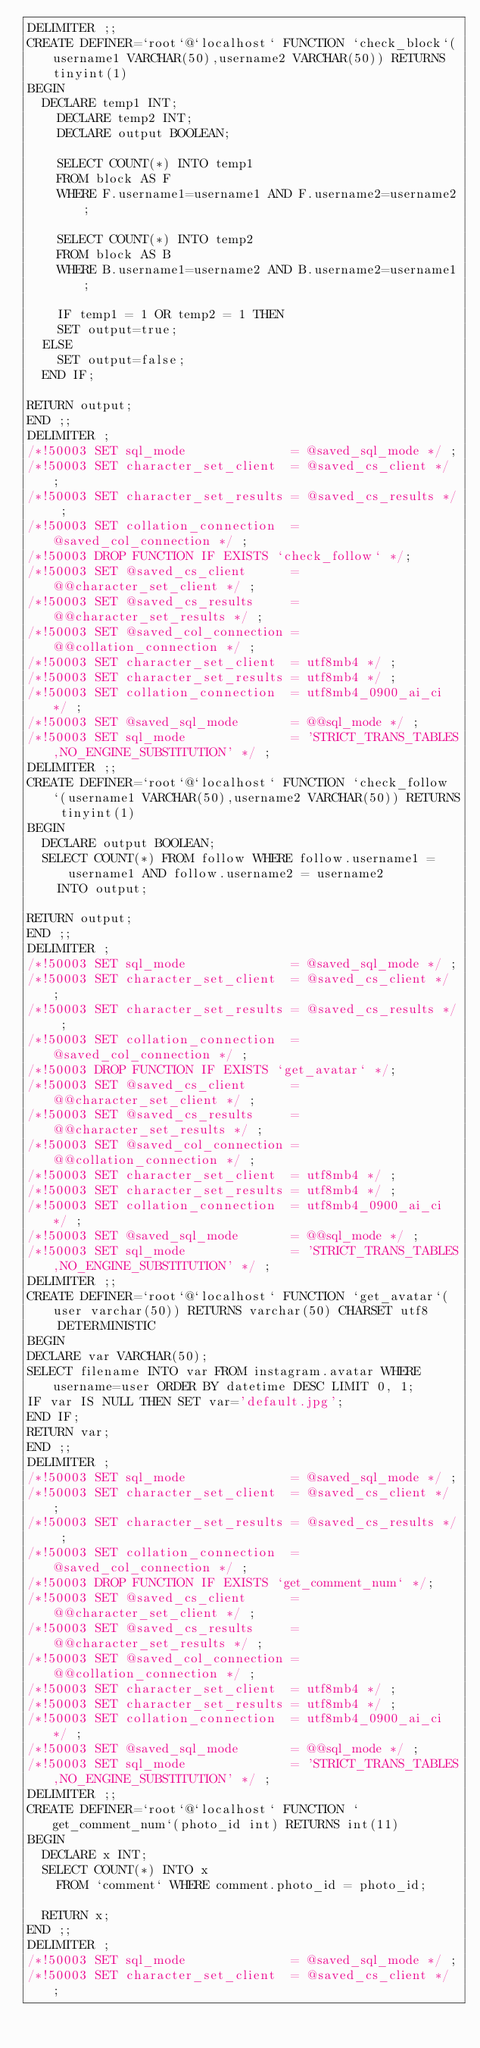Convert code to text. <code><loc_0><loc_0><loc_500><loc_500><_SQL_>DELIMITER ;;
CREATE DEFINER=`root`@`localhost` FUNCTION `check_block`(username1 VARCHAR(50),username2 VARCHAR(50)) RETURNS tinyint(1)
BEGIN
	DECLARE temp1 INT;
    DECLARE temp2 INT;
    DECLARE output BOOLEAN;
    
    SELECT COUNT(*) INTO temp1
    FROM block AS F
    WHERE F.username1=username1 AND F.username2=username2;
    
    SELECT COUNT(*) INTO temp2
    FROM block AS B
    WHERE B.username1=username2 AND B.username2=username1;
    
    IF temp1 = 1 OR temp2 = 1 THEN
		SET output=true;
	ELSE
		SET output=false;
	END IF;
    
RETURN output;
END ;;
DELIMITER ;
/*!50003 SET sql_mode              = @saved_sql_mode */ ;
/*!50003 SET character_set_client  = @saved_cs_client */ ;
/*!50003 SET character_set_results = @saved_cs_results */ ;
/*!50003 SET collation_connection  = @saved_col_connection */ ;
/*!50003 DROP FUNCTION IF EXISTS `check_follow` */;
/*!50003 SET @saved_cs_client      = @@character_set_client */ ;
/*!50003 SET @saved_cs_results     = @@character_set_results */ ;
/*!50003 SET @saved_col_connection = @@collation_connection */ ;
/*!50003 SET character_set_client  = utf8mb4 */ ;
/*!50003 SET character_set_results = utf8mb4 */ ;
/*!50003 SET collation_connection  = utf8mb4_0900_ai_ci */ ;
/*!50003 SET @saved_sql_mode       = @@sql_mode */ ;
/*!50003 SET sql_mode              = 'STRICT_TRANS_TABLES,NO_ENGINE_SUBSTITUTION' */ ;
DELIMITER ;;
CREATE DEFINER=`root`@`localhost` FUNCTION `check_follow`(username1 VARCHAR(50),username2 VARCHAR(50)) RETURNS tinyint(1)
BEGIN
	DECLARE output BOOLEAN;
	SELECT COUNT(*) FROM follow WHERE follow.username1 = username1 AND follow.username2 = username2
    INTO output;
    
RETURN output;
END ;;
DELIMITER ;
/*!50003 SET sql_mode              = @saved_sql_mode */ ;
/*!50003 SET character_set_client  = @saved_cs_client */ ;
/*!50003 SET character_set_results = @saved_cs_results */ ;
/*!50003 SET collation_connection  = @saved_col_connection */ ;
/*!50003 DROP FUNCTION IF EXISTS `get_avatar` */;
/*!50003 SET @saved_cs_client      = @@character_set_client */ ;
/*!50003 SET @saved_cs_results     = @@character_set_results */ ;
/*!50003 SET @saved_col_connection = @@collation_connection */ ;
/*!50003 SET character_set_client  = utf8mb4 */ ;
/*!50003 SET character_set_results = utf8mb4 */ ;
/*!50003 SET collation_connection  = utf8mb4_0900_ai_ci */ ;
/*!50003 SET @saved_sql_mode       = @@sql_mode */ ;
/*!50003 SET sql_mode              = 'STRICT_TRANS_TABLES,NO_ENGINE_SUBSTITUTION' */ ;
DELIMITER ;;
CREATE DEFINER=`root`@`localhost` FUNCTION `get_avatar`(user varchar(50)) RETURNS varchar(50) CHARSET utf8
    DETERMINISTIC
BEGIN
DECLARE var VARCHAR(50); 
SELECT filename INTO var FROM instagram.avatar WHERE username=user ORDER BY datetime DESC LIMIT 0, 1;
IF var IS NULL THEN SET var='default.jpg';
END IF;
RETURN var;
END ;;
DELIMITER ;
/*!50003 SET sql_mode              = @saved_sql_mode */ ;
/*!50003 SET character_set_client  = @saved_cs_client */ ;
/*!50003 SET character_set_results = @saved_cs_results */ ;
/*!50003 SET collation_connection  = @saved_col_connection */ ;
/*!50003 DROP FUNCTION IF EXISTS `get_comment_num` */;
/*!50003 SET @saved_cs_client      = @@character_set_client */ ;
/*!50003 SET @saved_cs_results     = @@character_set_results */ ;
/*!50003 SET @saved_col_connection = @@collation_connection */ ;
/*!50003 SET character_set_client  = utf8mb4 */ ;
/*!50003 SET character_set_results = utf8mb4 */ ;
/*!50003 SET collation_connection  = utf8mb4_0900_ai_ci */ ;
/*!50003 SET @saved_sql_mode       = @@sql_mode */ ;
/*!50003 SET sql_mode              = 'STRICT_TRANS_TABLES,NO_ENGINE_SUBSTITUTION' */ ;
DELIMITER ;;
CREATE DEFINER=`root`@`localhost` FUNCTION `get_comment_num`(photo_id int) RETURNS int(11)
BEGIN
	DECLARE x INT;
	SELECT COUNT(*) INTO x 
    FROM `comment` WHERE comment.photo_id = photo_id;
    
	RETURN x;
END ;;
DELIMITER ;
/*!50003 SET sql_mode              = @saved_sql_mode */ ;
/*!50003 SET character_set_client  = @saved_cs_client */ ;</code> 